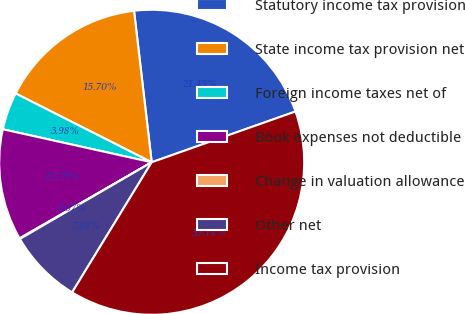Convert chart to OTSL. <chart><loc_0><loc_0><loc_500><loc_500><pie_chart><fcel>Statutory income tax provision<fcel>State income tax provision net<fcel>Foreign income taxes net of<fcel>Book expenses not deductible<fcel>Change in valuation allowance<fcel>Other net<fcel>Income tax provision<nl><fcel>21.45%<fcel>15.7%<fcel>3.98%<fcel>11.79%<fcel>0.07%<fcel>7.88%<fcel>39.14%<nl></chart> 